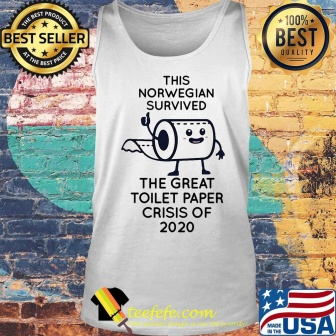Can you tell me more about the significance of these badges on the product? Certainly! The 'best seller' badge suggests that the item has been popular among customers, potentially appealing to those looking for trending or viral products. The '100% best quality' badge is an assurance of the product’s quality, aiming to instill confidence in potential buyers regarding the material or the print's durability. These badges are common marketing tactics used in online retail to attract buyers by highlighting the popularity and high standards of the merchandise. What does the 'USA' mark imply on this product? The 'USA' mark, along with the American design elements, likely indicates that the product is made in the United States or designed to appeal to American patriotism. It may also suggest that the product aligns with American values of resilience and humor, or it could be targeting customers who prefer products with local or national ties. 